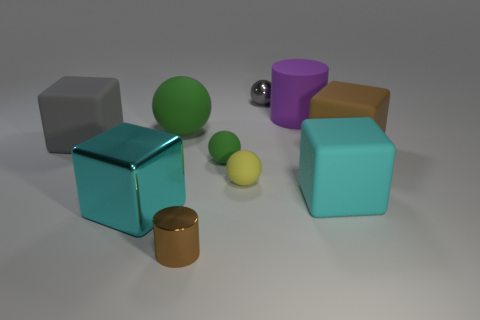Is there another large gray object that has the same shape as the big metal object?
Offer a very short reply. Yes. There is a green object that is right of the big green object; what shape is it?
Your response must be concise. Sphere. How many brown objects are on the left side of the matte cube in front of the green thing that is in front of the big green matte sphere?
Offer a very short reply. 1. Does the matte cube that is on the left side of the purple rubber object have the same color as the tiny metallic sphere?
Your answer should be compact. Yes. How many other objects are there of the same shape as the tiny green matte object?
Offer a terse response. 3. How many other things are there of the same material as the purple object?
Ensure brevity in your answer.  6. There is a green thing that is left of the cylinder that is in front of the large cyan thing right of the big cylinder; what is its material?
Provide a short and direct response. Rubber. Do the large sphere and the small cylinder have the same material?
Your answer should be very brief. No. How many cubes are either purple shiny things or yellow objects?
Offer a very short reply. 0. The tiny thing that is behind the big gray cube is what color?
Make the answer very short. Gray. 